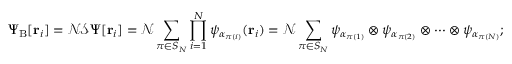<formula> <loc_0><loc_0><loc_500><loc_500>\Psi _ { B } [ r _ { i } ] = { \mathcal { N } } { \mathcal { S } } \Psi [ r _ { i } ] = { \mathcal { N } } \sum _ { \pi \in S _ { N } } \prod _ { i = 1 } ^ { N } \psi _ { \alpha _ { \pi ( i ) } } ( r _ { i } ) = { \mathcal { N } } \sum _ { \pi \in S _ { N } } \psi _ { \alpha _ { \pi ( 1 ) } } \otimes \psi _ { \alpha _ { \pi ( 2 ) } } \otimes \cdots \otimes \psi _ { \alpha _ { \pi ( N ) } } ;</formula> 